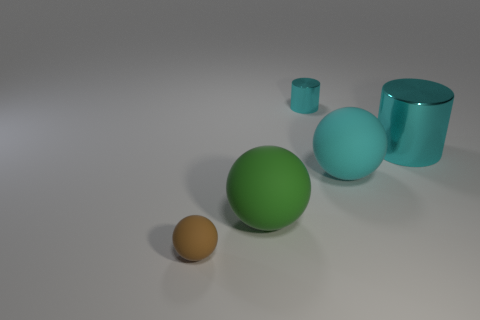Subtract all small brown rubber balls. How many balls are left? 2 Subtract all brown balls. How many balls are left? 2 Add 2 tiny gray metallic cylinders. How many objects exist? 7 Subtract all balls. How many objects are left? 2 Subtract 1 cylinders. How many cylinders are left? 1 Subtract all brown matte things. Subtract all small matte things. How many objects are left? 3 Add 5 big spheres. How many big spheres are left? 7 Add 3 tiny purple metal blocks. How many tiny purple metal blocks exist? 3 Subtract 0 brown blocks. How many objects are left? 5 Subtract all blue cylinders. Subtract all red blocks. How many cylinders are left? 2 